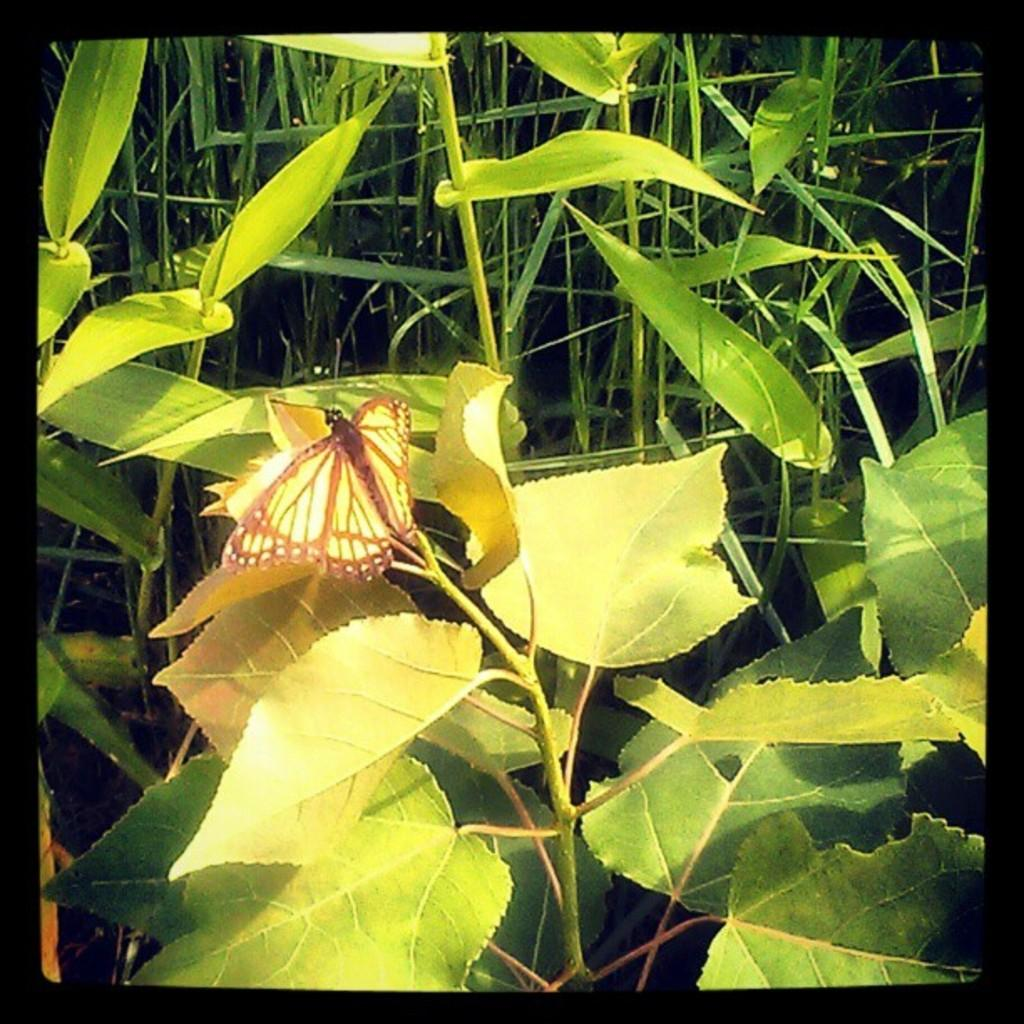What is the main subject of the image? There is a butterfly in the image. Where is the butterfly located? The butterfly is on a leaf. What type of vegetation can be seen in the image? There are green plants in the image. What type of motion can be seen in the image? There is no motion visible in the image; it is a still image of a butterfly on a leaf. Can you describe the patch of land where the butterfly is located? There is no specific patch of land mentioned in the image; it only shows a butterfly on a leaf surrounded by green plants. 